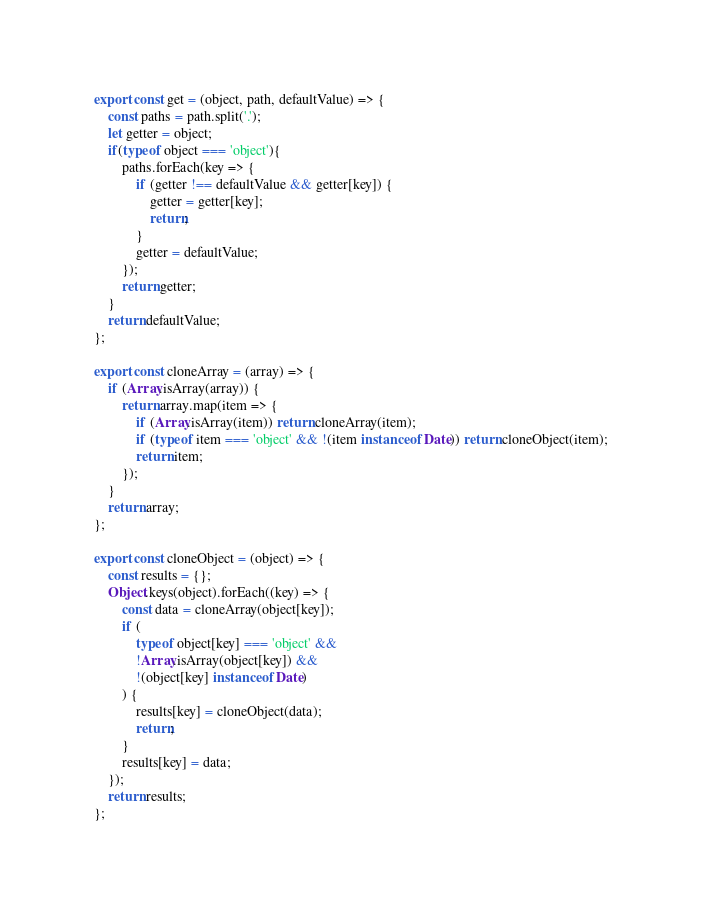<code> <loc_0><loc_0><loc_500><loc_500><_JavaScript_>export const get = (object, path, defaultValue) => {
    const paths = path.split('.');
    let getter = object;
    if(typeof object === 'object'){
        paths.forEach(key => {
            if (getter !== defaultValue && getter[key]) {
                getter = getter[key];
                return;
            }
            getter = defaultValue;
        });
        return getter;
    }
    return defaultValue;
};

export const cloneArray = (array) => {
    if (Array.isArray(array)) {
        return array.map(item => {
            if (Array.isArray(item)) return cloneArray(item);
            if (typeof item === 'object' && !(item instanceof Date)) return cloneObject(item);
            return item;
        });
    }
    return array;
};

export const cloneObject = (object) => {
    const results = {};
    Object.keys(object).forEach((key) => {
        const data = cloneArray(object[key]);
        if (
            typeof object[key] === 'object' &&
            !Array.isArray(object[key]) &&
            !(object[key] instanceof Date)
        ) {
            results[key] = cloneObject(data);
            return;
        }
        results[key] = data;
    });
    return results;
};
</code> 